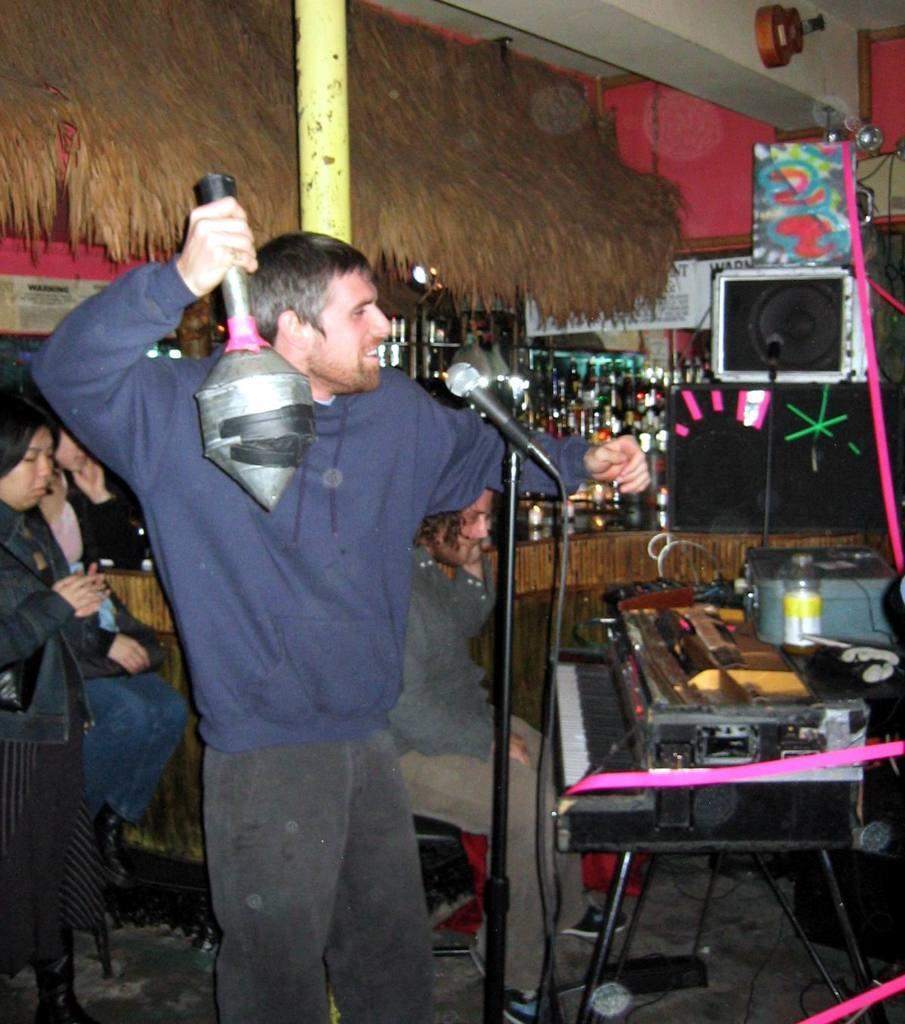Could you give a brief overview of what you see in this image? On the left side, there is a person holding an object, smiling and standing in front of a microphone which is attached to a stand. Behind him, there is a woman standing. In the background, there are other persons sitting, there are bottles, speakers, a musical instrument, a wall and other objects. 